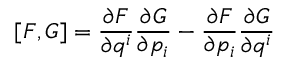Convert formula to latex. <formula><loc_0><loc_0><loc_500><loc_500>[ F , G ] = \frac { \partial F } { \partial q ^ { i } } \frac { \partial G } { \partial p _ { i } } - \frac { \partial F } { \partial p _ { i } } \frac { \partial G } { \partial q ^ { i } }</formula> 